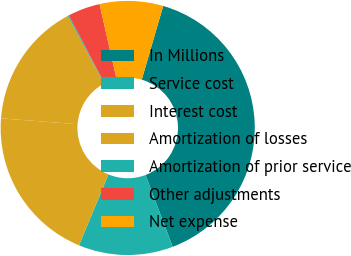<chart> <loc_0><loc_0><loc_500><loc_500><pie_chart><fcel>In Millions<fcel>Service cost<fcel>Interest cost<fcel>Amortization of losses<fcel>Amortization of prior service<fcel>Other adjustments<fcel>Net expense<nl><fcel>39.74%<fcel>12.02%<fcel>19.94%<fcel>15.98%<fcel>0.15%<fcel>4.11%<fcel>8.06%<nl></chart> 